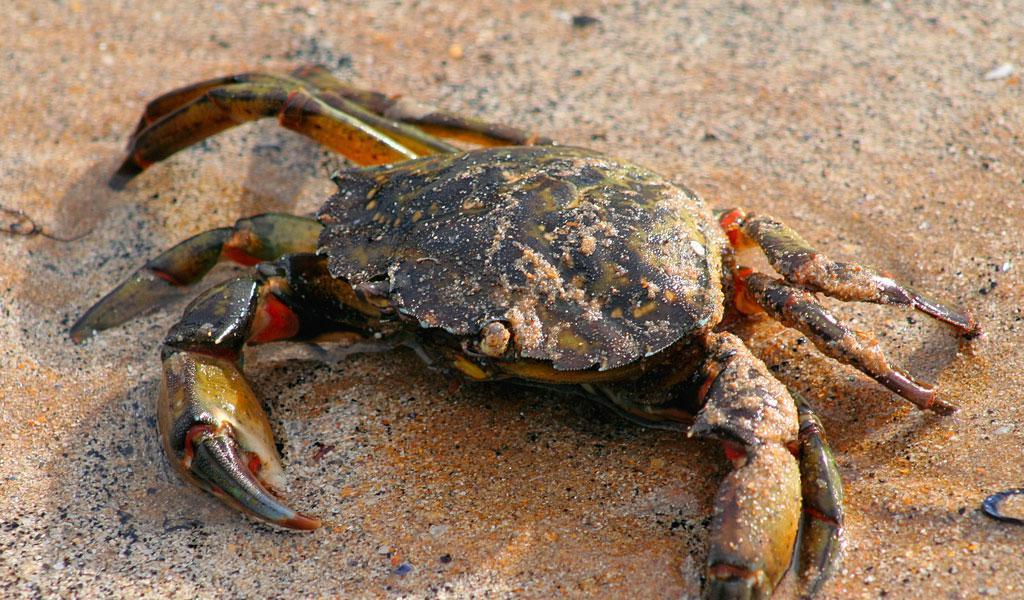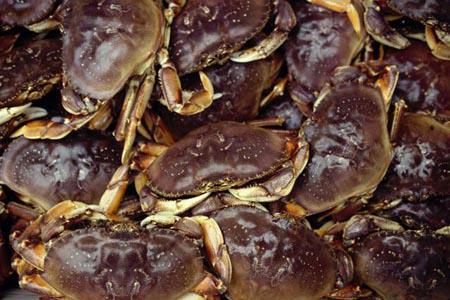The first image is the image on the left, the second image is the image on the right. For the images shown, is this caption "The right image contains one animal." true? Answer yes or no. No. The first image is the image on the left, the second image is the image on the right. For the images shown, is this caption "Eight or fewer crabs are visible." true? Answer yes or no. No. 